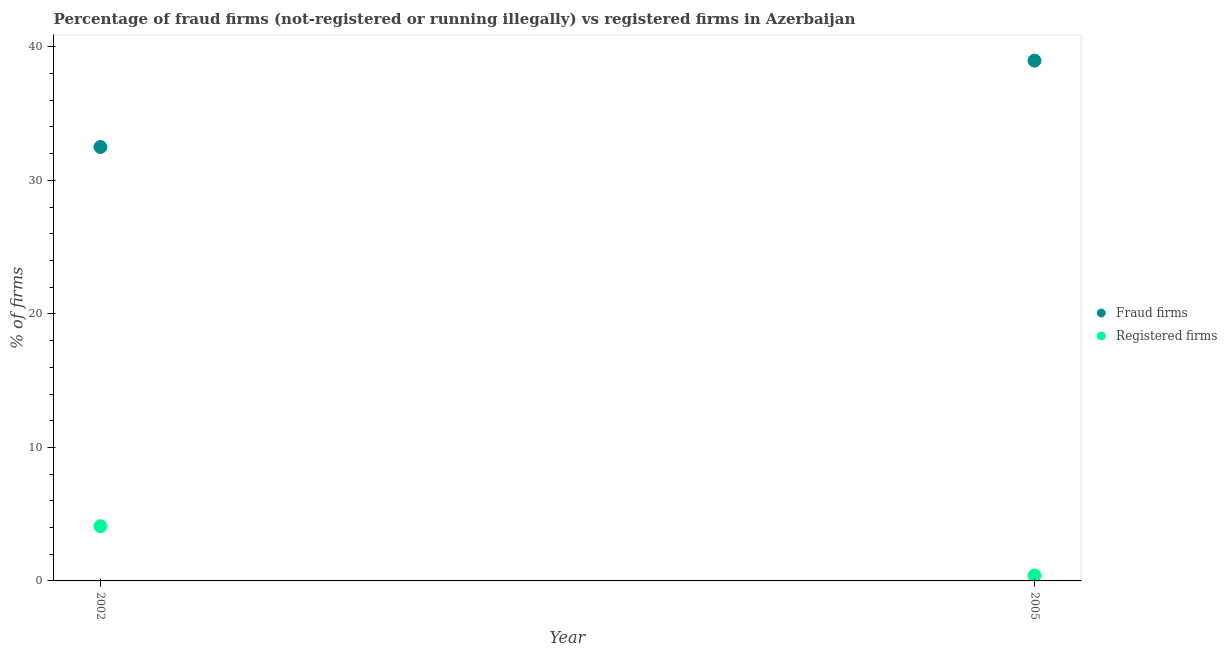How many different coloured dotlines are there?
Offer a very short reply. 2. What is the percentage of fraud firms in 2002?
Keep it short and to the point. 32.5. Across all years, what is the maximum percentage of fraud firms?
Keep it short and to the point. 38.97. Across all years, what is the minimum percentage of fraud firms?
Ensure brevity in your answer.  32.5. In which year was the percentage of fraud firms minimum?
Offer a terse response. 2002. What is the total percentage of fraud firms in the graph?
Keep it short and to the point. 71.47. What is the difference between the percentage of registered firms in 2002 and that in 2005?
Keep it short and to the point. 3.7. What is the difference between the percentage of registered firms in 2002 and the percentage of fraud firms in 2005?
Your answer should be very brief. -34.87. What is the average percentage of fraud firms per year?
Ensure brevity in your answer.  35.73. In the year 2002, what is the difference between the percentage of fraud firms and percentage of registered firms?
Ensure brevity in your answer.  28.4. What is the ratio of the percentage of fraud firms in 2002 to that in 2005?
Your answer should be compact. 0.83. In how many years, is the percentage of registered firms greater than the average percentage of registered firms taken over all years?
Ensure brevity in your answer.  1. Is the percentage of registered firms strictly greater than the percentage of fraud firms over the years?
Your answer should be very brief. No. How many dotlines are there?
Ensure brevity in your answer.  2. Are the values on the major ticks of Y-axis written in scientific E-notation?
Offer a very short reply. No. Does the graph contain any zero values?
Provide a short and direct response. No. Does the graph contain grids?
Offer a terse response. No. Where does the legend appear in the graph?
Your answer should be very brief. Center right. How many legend labels are there?
Keep it short and to the point. 2. How are the legend labels stacked?
Make the answer very short. Vertical. What is the title of the graph?
Give a very brief answer. Percentage of fraud firms (not-registered or running illegally) vs registered firms in Azerbaijan. Does "Age 65(male)" appear as one of the legend labels in the graph?
Make the answer very short. No. What is the label or title of the Y-axis?
Your response must be concise. % of firms. What is the % of firms of Fraud firms in 2002?
Your answer should be compact. 32.5. What is the % of firms in Fraud firms in 2005?
Offer a terse response. 38.97. Across all years, what is the maximum % of firms in Fraud firms?
Ensure brevity in your answer.  38.97. Across all years, what is the minimum % of firms in Fraud firms?
Offer a very short reply. 32.5. Across all years, what is the minimum % of firms in Registered firms?
Your answer should be compact. 0.4. What is the total % of firms in Fraud firms in the graph?
Give a very brief answer. 71.47. What is the total % of firms of Registered firms in the graph?
Make the answer very short. 4.5. What is the difference between the % of firms of Fraud firms in 2002 and that in 2005?
Ensure brevity in your answer.  -6.47. What is the difference between the % of firms of Fraud firms in 2002 and the % of firms of Registered firms in 2005?
Offer a terse response. 32.1. What is the average % of firms in Fraud firms per year?
Your response must be concise. 35.73. What is the average % of firms of Registered firms per year?
Provide a succinct answer. 2.25. In the year 2002, what is the difference between the % of firms of Fraud firms and % of firms of Registered firms?
Your answer should be compact. 28.4. In the year 2005, what is the difference between the % of firms of Fraud firms and % of firms of Registered firms?
Your answer should be compact. 38.57. What is the ratio of the % of firms of Fraud firms in 2002 to that in 2005?
Offer a terse response. 0.83. What is the ratio of the % of firms of Registered firms in 2002 to that in 2005?
Provide a succinct answer. 10.25. What is the difference between the highest and the second highest % of firms of Fraud firms?
Offer a terse response. 6.47. What is the difference between the highest and the lowest % of firms of Fraud firms?
Offer a very short reply. 6.47. 